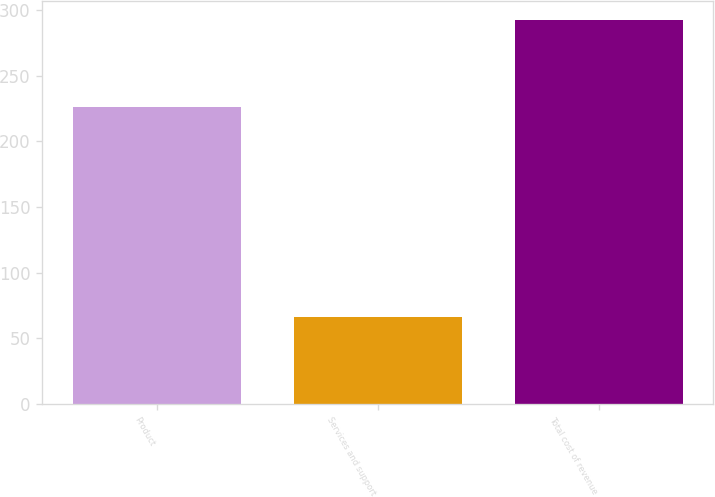Convert chart. <chart><loc_0><loc_0><loc_500><loc_500><bar_chart><fcel>Product<fcel>Services and support<fcel>Total cost of revenue<nl><fcel>226.5<fcel>66<fcel>292.5<nl></chart> 